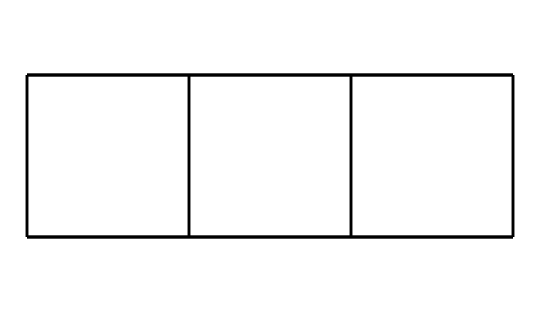What is the molecular formula of cubane? Cubane consists of 8 carbon atoms and 8 hydrogen atoms, which can be derived from counting the atoms in the SMILES representation. Therefore, the molecular formula is C8H8.
Answer: C8H8 How many carbon atoms are in cubane? By analyzing the SMILES notation, we can identify that there are 8 Carbon (C) atoms present in the structure.
Answer: 8 Is cubane a saturated or unsaturated compound? Cubane has single bonds between all carbon atoms, indicating that it is saturated. Saturation means that it contains no double or triple bonds between carbon atoms.
Answer: saturated What type of geometry does cubane exhibit? The arrangement of cubane leads to a cubic geometry due to its cage structure, which allows for its unique spatial arrangement of atoms in three dimensions.
Answer: cubic How many hydrogen atoms are attached to each carbon atom in cubane? Each carbon atom in cubane is bonded to two hydrogen atoms, which can be concluded from the saturation and the arrangement in the cubic geometry.
Answer: 2 What is a unique feature of cage compounds like cubane? Cage compounds are characterized by their closed three-dimensional structures, which provide unique properties such as high stability and potential applications in high-energy storage.
Answer: closed structure What is one potential application of cubane? Cubane has potential applications in high-energy computer storage devices due to its high energy density derived from its stable cubic structure.
Answer: high-energy storage 